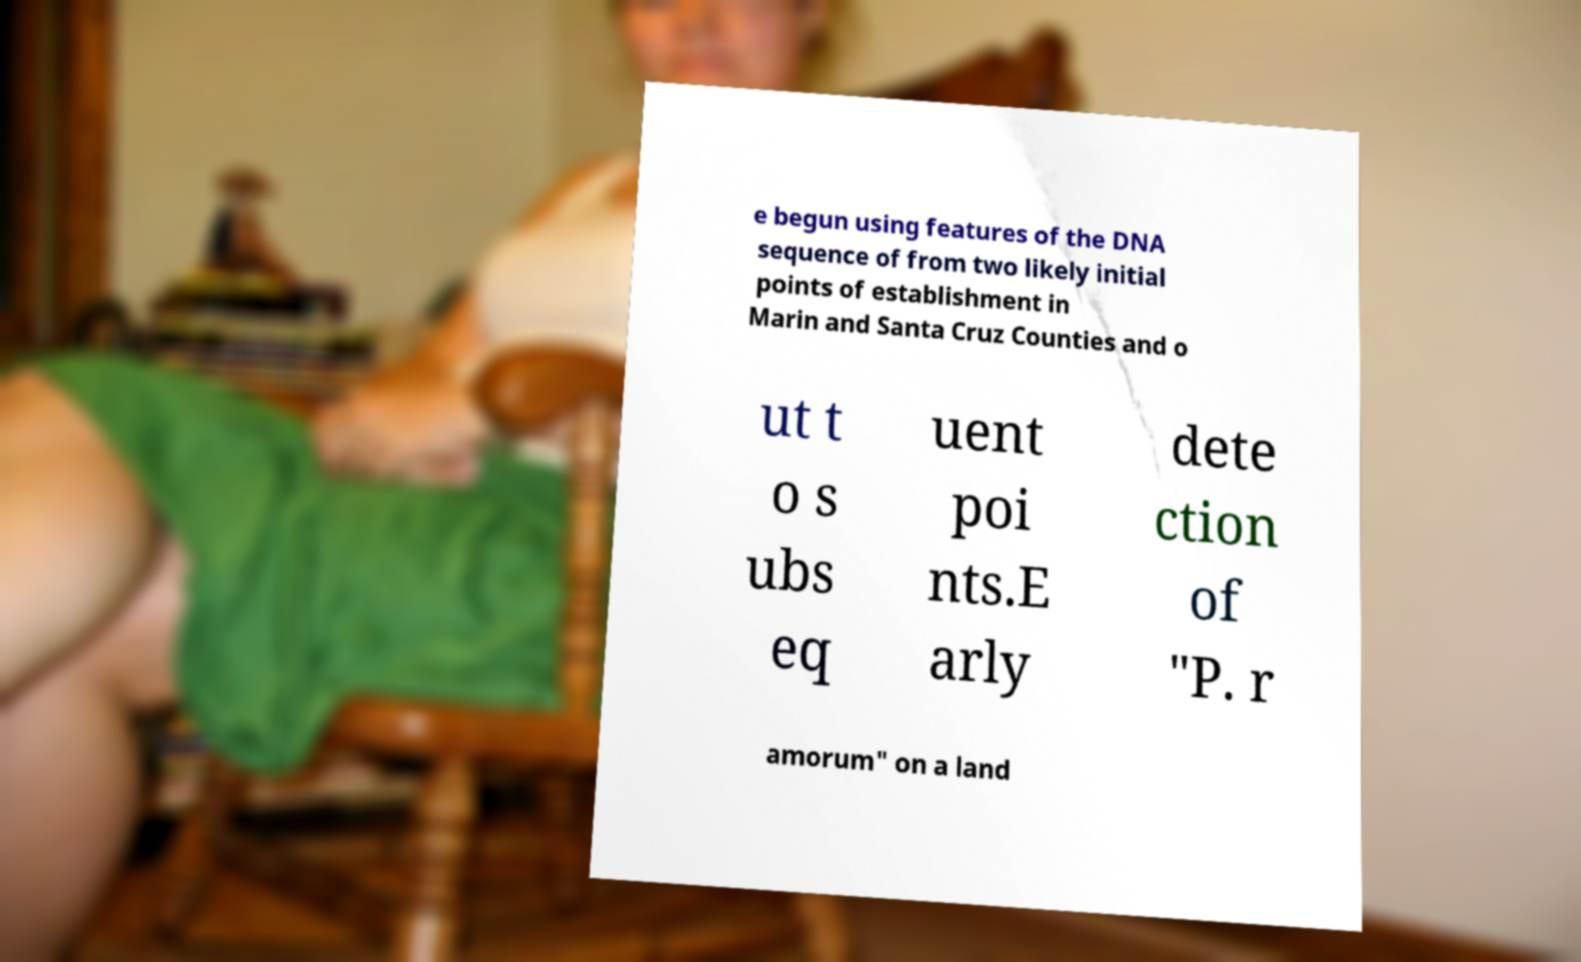There's text embedded in this image that I need extracted. Can you transcribe it verbatim? e begun using features of the DNA sequence of from two likely initial points of establishment in Marin and Santa Cruz Counties and o ut t o s ubs eq uent poi nts.E arly dete ction of "P. r amorum" on a land 